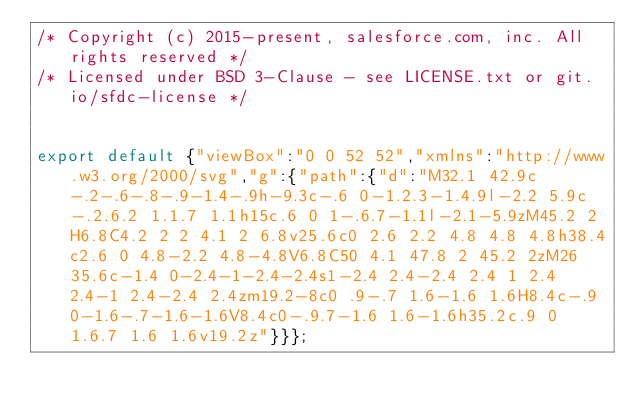Convert code to text. <code><loc_0><loc_0><loc_500><loc_500><_JavaScript_>/* Copyright (c) 2015-present, salesforce.com, inc. All rights reserved */
/* Licensed under BSD 3-Clause - see LICENSE.txt or git.io/sfdc-license */


export default {"viewBox":"0 0 52 52","xmlns":"http://www.w3.org/2000/svg","g":{"path":{"d":"M32.1 42.9c-.2-.6-.8-.9-1.4-.9h-9.3c-.6 0-1.2.3-1.4.9l-2.2 5.9c-.2.6.2 1.1.7 1.1h15c.6 0 1-.6.7-1.1l-2.1-5.9zM45.2 2H6.8C4.2 2 2 4.1 2 6.8v25.6c0 2.6 2.2 4.8 4.8 4.8h38.4c2.6 0 4.8-2.2 4.8-4.8V6.8C50 4.1 47.8 2 45.2 2zM26 35.6c-1.4 0-2.4-1-2.4-2.4s1-2.4 2.4-2.4 2.4 1 2.4 2.4-1 2.4-2.4 2.4zm19.2-8c0 .9-.7 1.6-1.6 1.6H8.4c-.9 0-1.6-.7-1.6-1.6V8.4c0-.9.7-1.6 1.6-1.6h35.2c.9 0 1.6.7 1.6 1.6v19.2z"}}};
</code> 